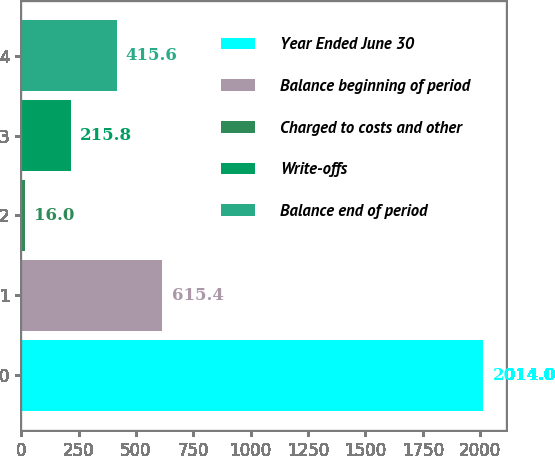Convert chart. <chart><loc_0><loc_0><loc_500><loc_500><bar_chart><fcel>Year Ended June 30<fcel>Balance beginning of period<fcel>Charged to costs and other<fcel>Write-offs<fcel>Balance end of period<nl><fcel>2014<fcel>615.4<fcel>16<fcel>215.8<fcel>415.6<nl></chart> 